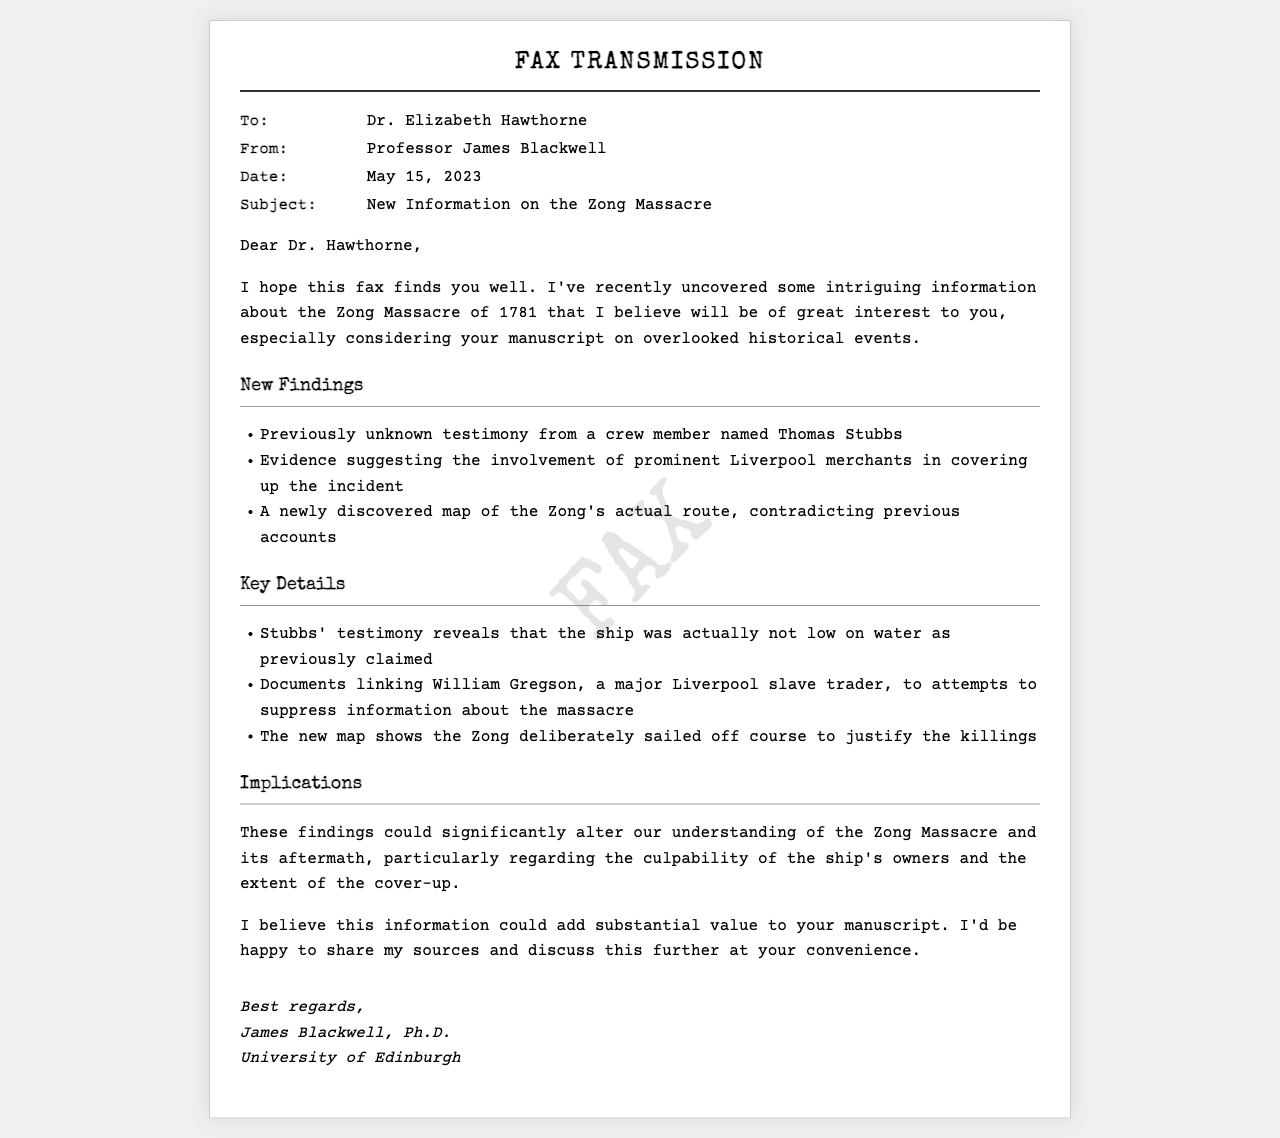what is the date of the fax? The date mentioned in the fax is May 15, 2023.
Answer: May 15, 2023 who is the sender of the fax? The sender of the fax is Professor James Blackwell.
Answer: Professor James Blackwell what significant piece of testimony was uncovered? The fax mentions previously unknown testimony from a crew member named Thomas Stubbs.
Answer: Thomas Stubbs which merchant was linked to the cover-up attempts? The fax indicates William Gregson, a major Liverpool slave trader.
Answer: William Gregson what was revealed about the ship's water situation? Stubbs' testimony reveals that the ship was actually not low on water as previously claimed.
Answer: Not low on water what is the implication of the new map discovered? The new map shows the Zong deliberately sailed off course to justify the killings.
Answer: Sailed off course how does this new information affect the understanding of the Zong Massacre? These findings could significantly alter our understanding of the Zong Massacre and its aftermath.
Answer: Alter understanding what is the subject of the fax? The subject of the fax concerns new information on the Zong Massacre.
Answer: New Information on the Zong Massacre how does the sender suggest to share the information? The sender mentions being happy to share sources and discuss further at the recipient's convenience.
Answer: Share sources and discuss further 